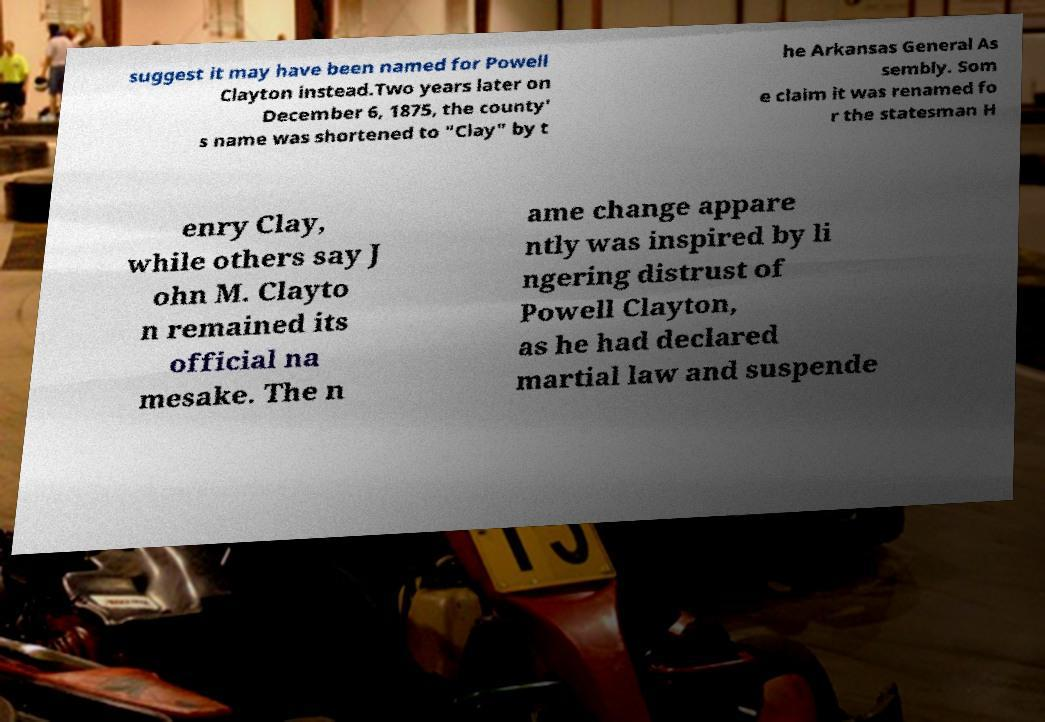Could you extract and type out the text from this image? suggest it may have been named for Powell Clayton instead.Two years later on December 6, 1875, the county' s name was shortened to "Clay" by t he Arkansas General As sembly. Som e claim it was renamed fo r the statesman H enry Clay, while others say J ohn M. Clayto n remained its official na mesake. The n ame change appare ntly was inspired by li ngering distrust of Powell Clayton, as he had declared martial law and suspende 